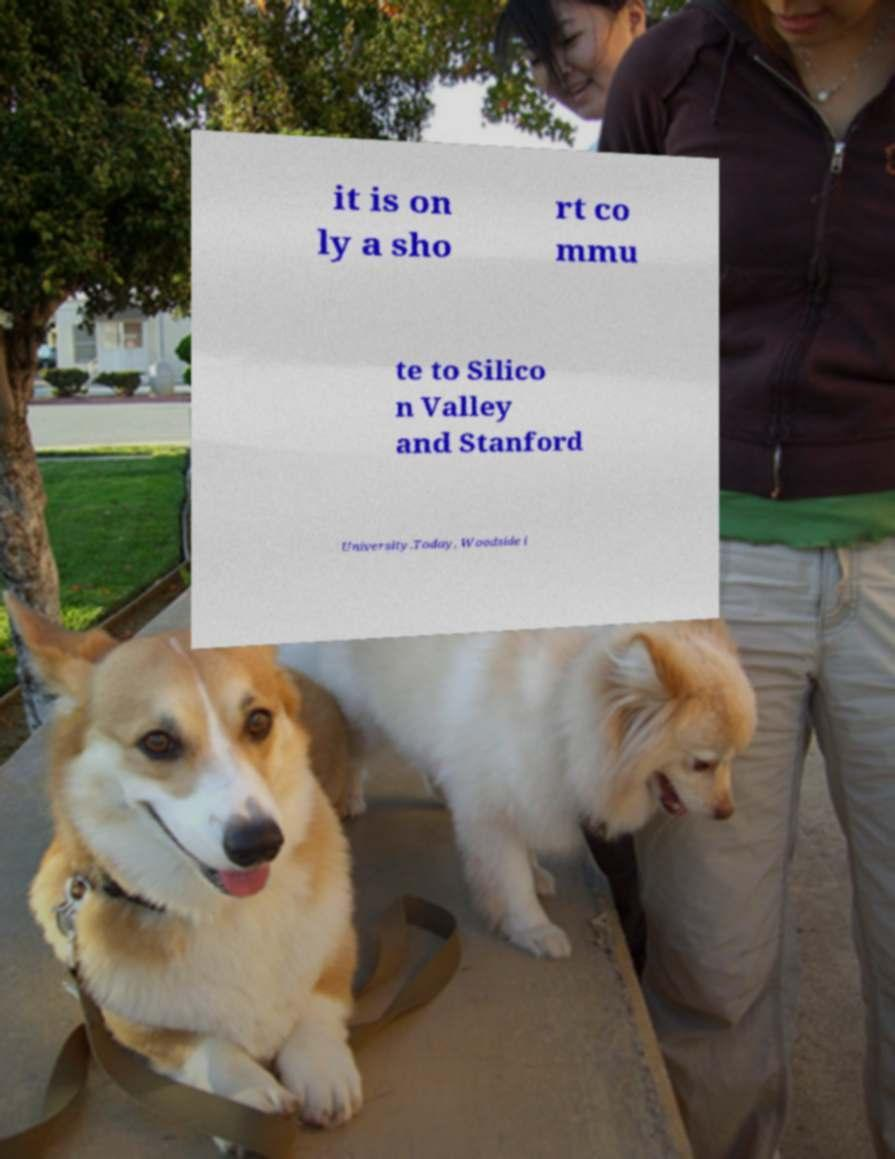Please identify and transcribe the text found in this image. it is on ly a sho rt co mmu te to Silico n Valley and Stanford University.Today, Woodside i 